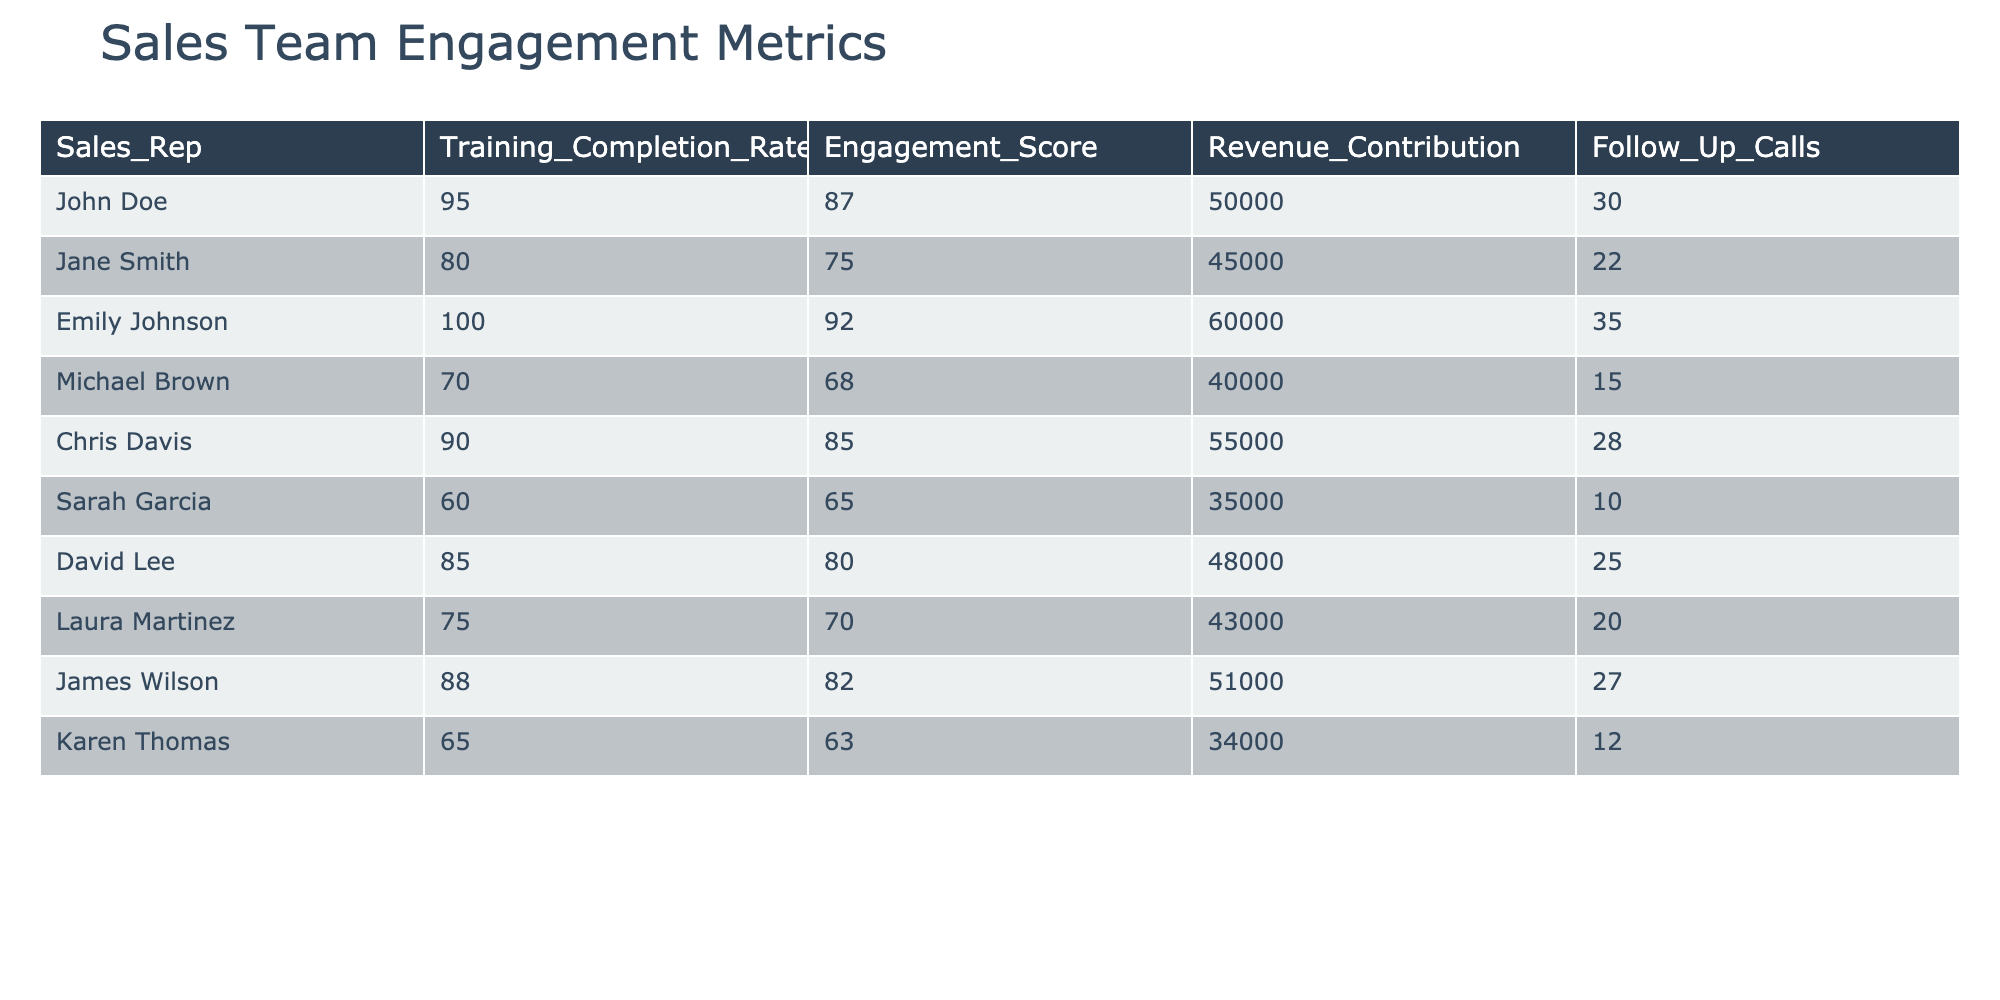What's the highest training completion rate among the sales representatives? By examining the 'Training_Completion_Rate' column, we find that Emily Johnson has the highest rate, which is 100%.
Answer: 100% Which sales representative has the lowest engagement score? Referring to the 'Engagement_Score' column, Michael Brown has the lowest score of 68.
Answer: 68 What is the total revenue contribution from sales representatives who completed training successfully (above 80%)? The representatives with above 80% training completion rates are John Doe (50000), Emily Johnson (60000), Chris Davis (55000), and David Lee (48000). Summing these gives 50000 + 60000 + 55000 + 48000 = 213000.
Answer: 213000 Is Sarah Garcia's engagement score higher than her training completion rate? Sarah Garcia has an engagement score of 65 and a training completion rate of 60%. Since 65 > 60, the answer is yes.
Answer: Yes Find the average follow-up calls made by sales representatives who completed training at least 80%. The representatives with at least 80% training completion are John Doe (30), Emily Johnson (35), Chris Davis (28), and David Lee (25). Their average is (30 + 35 + 28 + 25) / 4 = 29.5.
Answer: 29.5 Which sales representative contributed the most revenue, and what was the amount? Looking at the 'Revenue_Contribution' column, Emily Johnson contributed the most revenue at 60000.
Answer: 60000 How many follow-up calls did Michael Brown make compared to John Doe? Michael Brown made 15 follow-up calls while John Doe made 30. Comparing these, 15 is less than 30.
Answer: 15 What is the difference in engagement scores between the highest and lowest performer? The highest engagement score is 92 (Emily Johnson), and the lowest is 68 (Michael Brown), so the difference is 92 - 68 = 24.
Answer: 24 Do any sales representatives with a training completion rate of 85% or more also have an engagement score below 80? Checking the data, David Lee has a training completion rate of 85% and an engagement score of 80. Since 80 is not below 80, the answer is no representatives meet these criteria.
Answer: No 